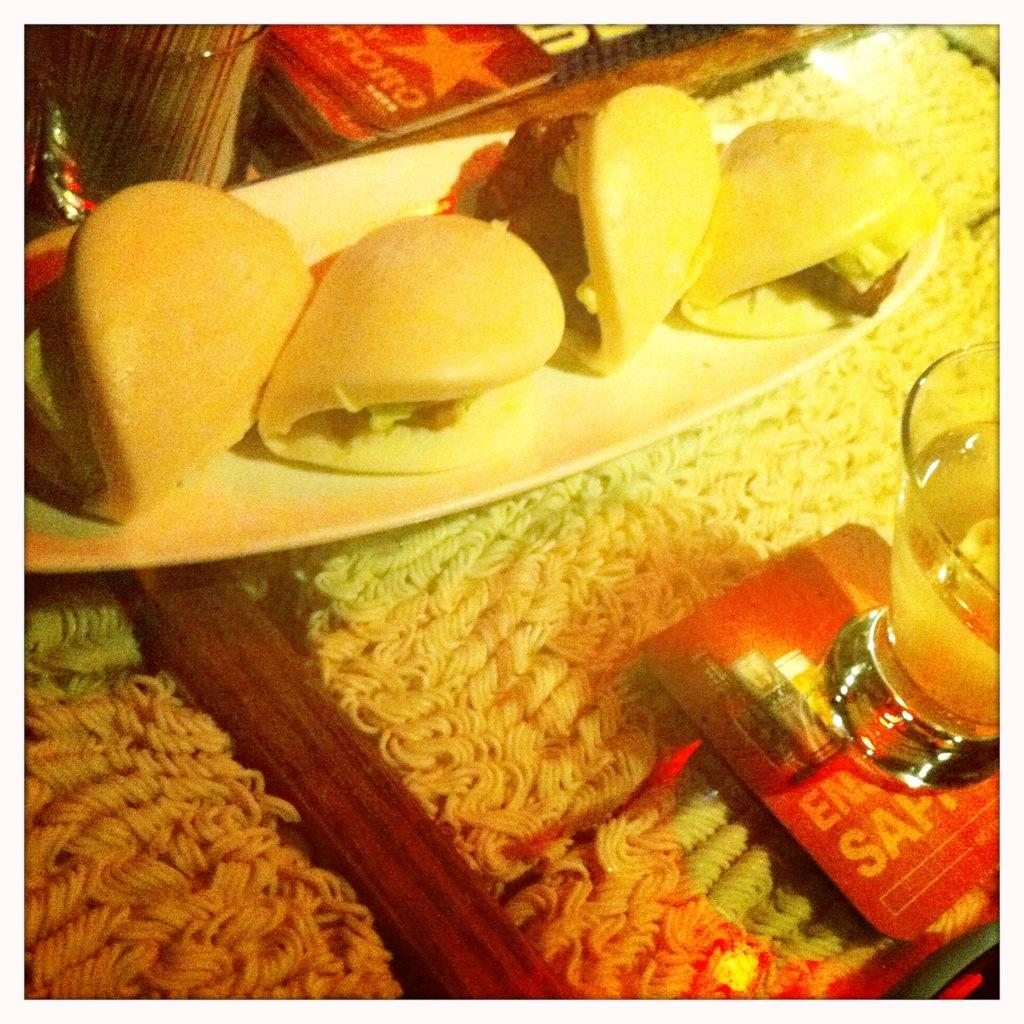What type of food is visible in the image? Noodles are present in the image. What type of nutrient is present in the noodles? Carbs are present in the image. What type of dishware is visible in the image? There are glasses and a plate in the image. Can you describe the overall content of the image? Food is visible in the image. What type of organization is hosting the competition in the image? There is no competition or organization present in the image; it features noodles, carbs, glasses, and a plate. 